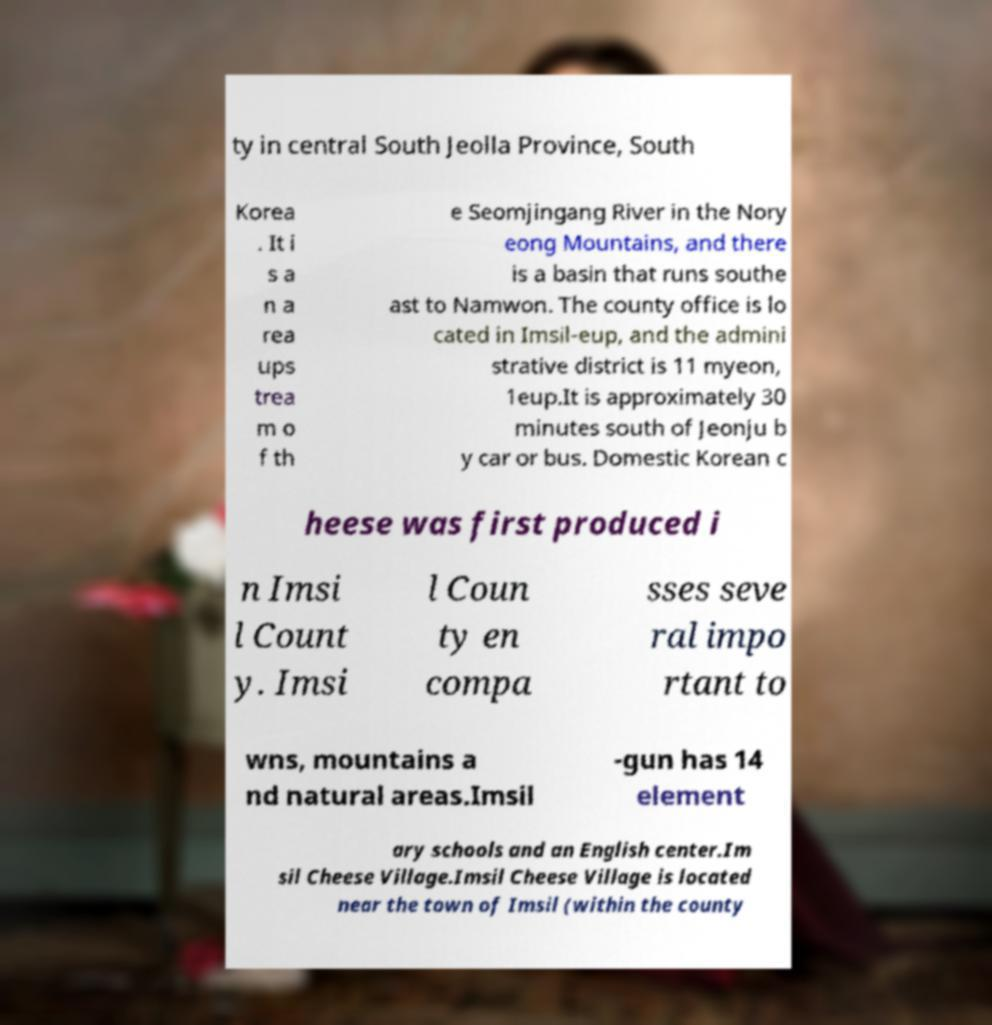Can you read and provide the text displayed in the image?This photo seems to have some interesting text. Can you extract and type it out for me? ty in central South Jeolla Province, South Korea . It i s a n a rea ups trea m o f th e Seomjingang River in the Nory eong Mountains, and there is a basin that runs southe ast to Namwon. The county office is lo cated in Imsil-eup, and the admini strative district is 11 myeon, 1eup.It is approximately 30 minutes south of Jeonju b y car or bus. Domestic Korean c heese was first produced i n Imsi l Count y. Imsi l Coun ty en compa sses seve ral impo rtant to wns, mountains a nd natural areas.Imsil -gun has 14 element ary schools and an English center.Im sil Cheese Village.Imsil Cheese Village is located near the town of Imsil (within the county 